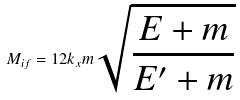<formula> <loc_0><loc_0><loc_500><loc_500>M _ { i f } = 1 2 k _ { x } m \sqrt { \frac { E + m } { E ^ { \prime } + m } }</formula> 